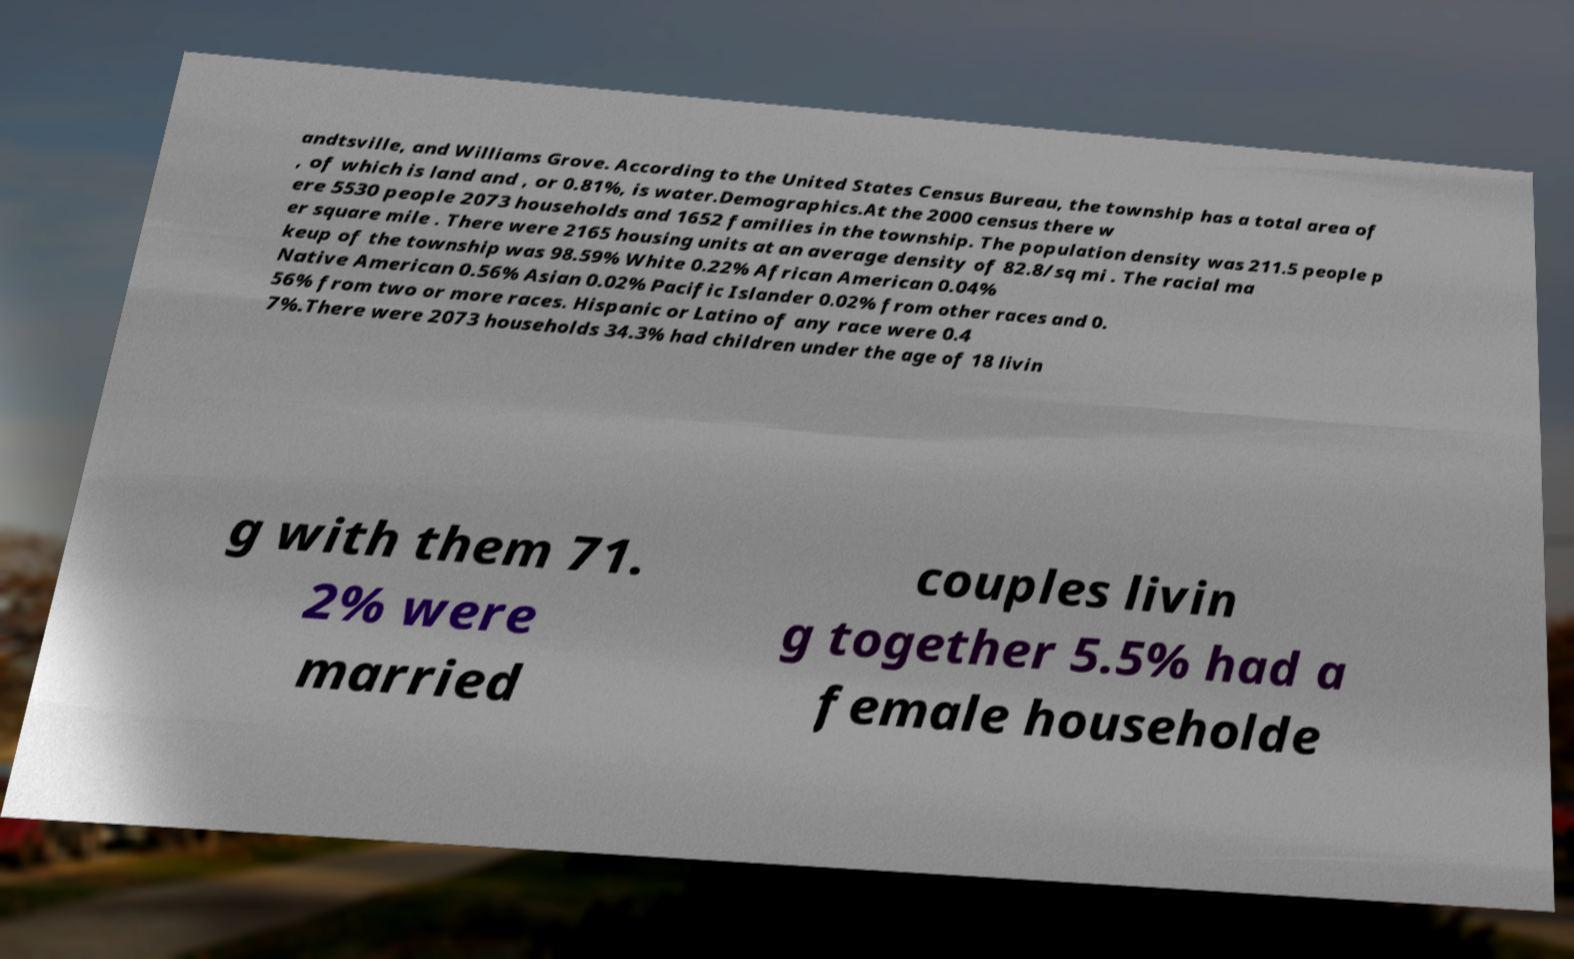Could you assist in decoding the text presented in this image and type it out clearly? andtsville, and Williams Grove. According to the United States Census Bureau, the township has a total area of , of which is land and , or 0.81%, is water.Demographics.At the 2000 census there w ere 5530 people 2073 households and 1652 families in the township. The population density was 211.5 people p er square mile . There were 2165 housing units at an average density of 82.8/sq mi . The racial ma keup of the township was 98.59% White 0.22% African American 0.04% Native American 0.56% Asian 0.02% Pacific Islander 0.02% from other races and 0. 56% from two or more races. Hispanic or Latino of any race were 0.4 7%.There were 2073 households 34.3% had children under the age of 18 livin g with them 71. 2% were married couples livin g together 5.5% had a female householde 